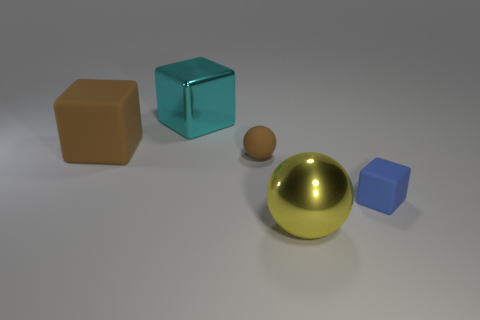How many cyan blocks have the same size as the yellow metallic thing?
Give a very brief answer. 1. There is a tiny rubber thing left of the large yellow metal thing; how many matte things are behind it?
Offer a terse response. 1. Do the rubber block to the right of the small brown matte thing and the big matte block have the same color?
Offer a terse response. No. There is a matte object that is right of the big object in front of the brown block; is there a large cyan cube that is to the right of it?
Ensure brevity in your answer.  No. The thing that is in front of the tiny sphere and behind the big sphere has what shape?
Make the answer very short. Cube. Are there any small objects of the same color as the big metallic block?
Provide a short and direct response. No. The shiny thing behind the tiny matte object that is on the right side of the brown ball is what color?
Offer a terse response. Cyan. What size is the metallic object that is in front of the brown rubber object that is to the right of the metallic thing that is behind the large yellow metal ball?
Provide a succinct answer. Large. Are the large cyan block and the big thing to the right of the big shiny cube made of the same material?
Your response must be concise. Yes. There is a cube that is made of the same material as the yellow sphere; what is its size?
Your response must be concise. Large. 